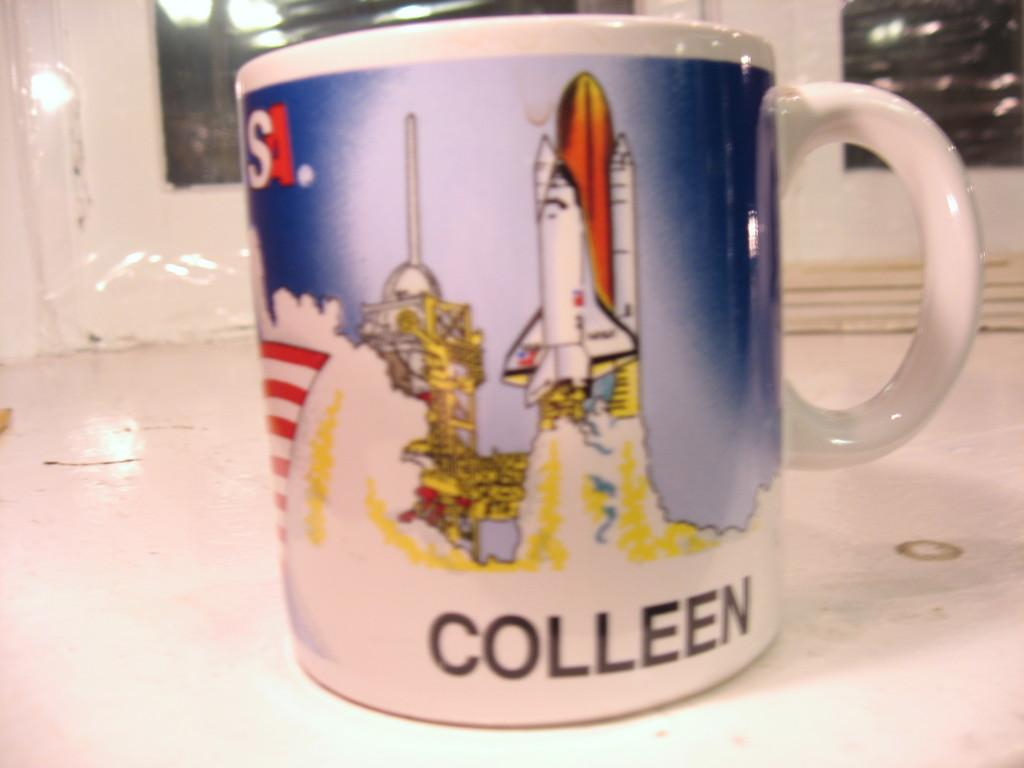Provide a one-sentence caption for the provided image. A space shuttle launch mug is personalized for Colleen. 